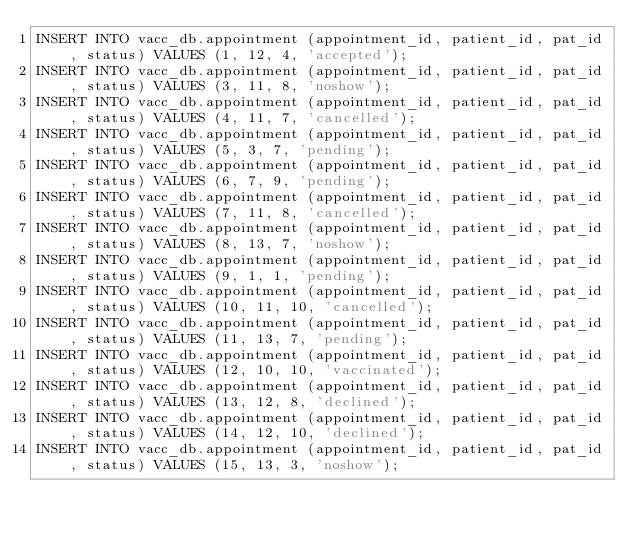Convert code to text. <code><loc_0><loc_0><loc_500><loc_500><_SQL_>INSERT INTO vacc_db.appointment (appointment_id, patient_id, pat_id, status) VALUES (1, 12, 4, 'accepted');
INSERT INTO vacc_db.appointment (appointment_id, patient_id, pat_id, status) VALUES (3, 11, 8, 'noshow');
INSERT INTO vacc_db.appointment (appointment_id, patient_id, pat_id, status) VALUES (4, 11, 7, 'cancelled');
INSERT INTO vacc_db.appointment (appointment_id, patient_id, pat_id, status) VALUES (5, 3, 7, 'pending');
INSERT INTO vacc_db.appointment (appointment_id, patient_id, pat_id, status) VALUES (6, 7, 9, 'pending');
INSERT INTO vacc_db.appointment (appointment_id, patient_id, pat_id, status) VALUES (7, 11, 8, 'cancelled');
INSERT INTO vacc_db.appointment (appointment_id, patient_id, pat_id, status) VALUES (8, 13, 7, 'noshow');
INSERT INTO vacc_db.appointment (appointment_id, patient_id, pat_id, status) VALUES (9, 1, 1, 'pending');
INSERT INTO vacc_db.appointment (appointment_id, patient_id, pat_id, status) VALUES (10, 11, 10, 'cancelled');
INSERT INTO vacc_db.appointment (appointment_id, patient_id, pat_id, status) VALUES (11, 13, 7, 'pending');
INSERT INTO vacc_db.appointment (appointment_id, patient_id, pat_id, status) VALUES (12, 10, 10, 'vaccinated');
INSERT INTO vacc_db.appointment (appointment_id, patient_id, pat_id, status) VALUES (13, 12, 8, 'declined');
INSERT INTO vacc_db.appointment (appointment_id, patient_id, pat_id, status) VALUES (14, 12, 10, 'declined');
INSERT INTO vacc_db.appointment (appointment_id, patient_id, pat_id, status) VALUES (15, 13, 3, 'noshow');</code> 